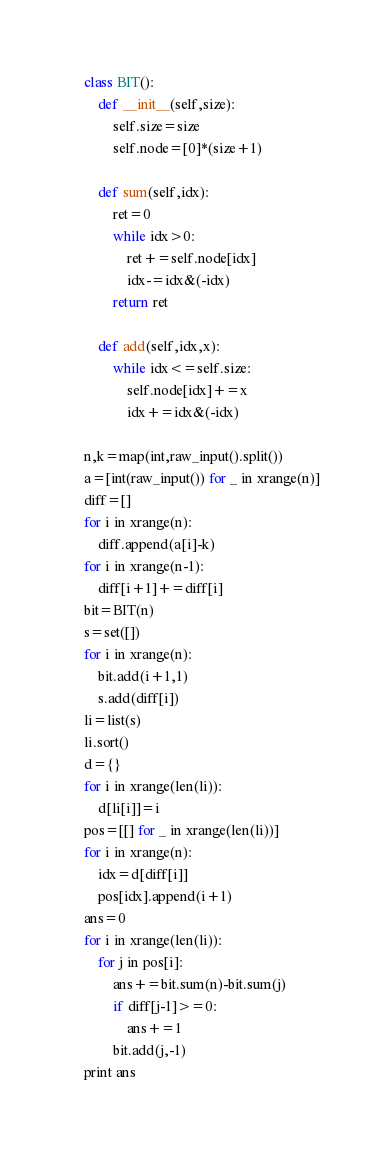<code> <loc_0><loc_0><loc_500><loc_500><_Python_>class BIT():
    def __init__(self,size):
        self.size=size
        self.node=[0]*(size+1)

    def sum(self,idx):
        ret=0
        while idx>0:
            ret+=self.node[idx]
            idx-=idx&(-idx)
        return ret

    def add(self,idx,x):
        while idx<=self.size:
            self.node[idx]+=x
            idx+=idx&(-idx)

n,k=map(int,raw_input().split())
a=[int(raw_input()) for _ in xrange(n)]
diff=[]
for i in xrange(n):
    diff.append(a[i]-k)
for i in xrange(n-1):
    diff[i+1]+=diff[i]
bit=BIT(n)
s=set([])
for i in xrange(n):
    bit.add(i+1,1)
    s.add(diff[i])
li=list(s)
li.sort()
d={}
for i in xrange(len(li)):
    d[li[i]]=i
pos=[[] for _ in xrange(len(li))]
for i in xrange(n):
    idx=d[diff[i]]
    pos[idx].append(i+1)
ans=0
for i in xrange(len(li)):
    for j in pos[i]:
        ans+=bit.sum(n)-bit.sum(j)
        if diff[j-1]>=0:
            ans+=1
        bit.add(j,-1)
print ans
</code> 